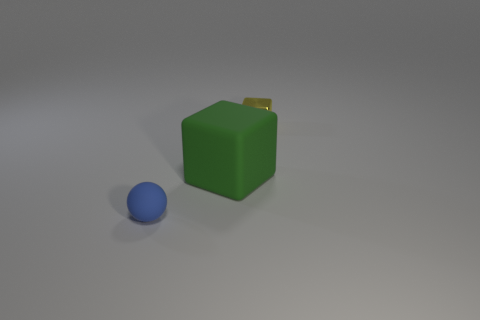There is a cube that is on the right side of the large matte thing; what size is it?
Your answer should be very brief. Small. What number of blue spheres have the same size as the shiny object?
Your answer should be very brief. 1. What is the color of the rubber ball that is the same size as the yellow block?
Your answer should be compact. Blue. What is the color of the small metal block?
Offer a terse response. Yellow. What material is the small object right of the big matte thing?
Provide a short and direct response. Metal. What is the size of the yellow object that is the same shape as the green rubber thing?
Provide a succinct answer. Small. Are there fewer big matte blocks that are in front of the blue matte object than rubber objects?
Offer a terse response. Yes. Is there a small yellow object?
Your answer should be very brief. Yes. The large matte object that is the same shape as the tiny yellow object is what color?
Offer a terse response. Green. Is the size of the yellow shiny block the same as the green thing?
Keep it short and to the point. No. 